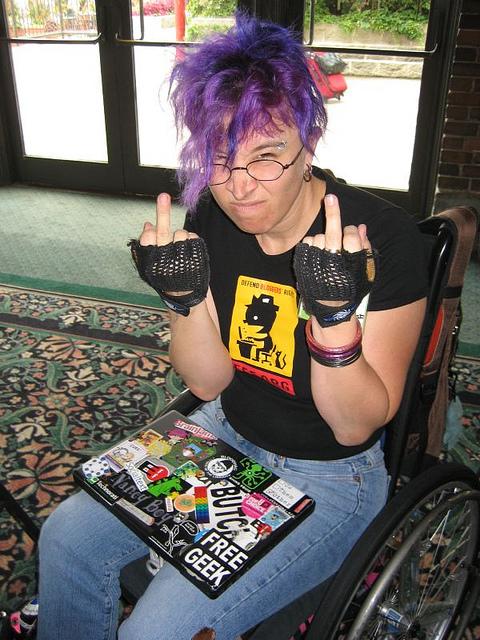Is the girl inside or outside?
Quick response, please. Inside. What color is the girls hair?
Write a very short answer. Purple. Does this person respect authority?
Answer briefly. No. 